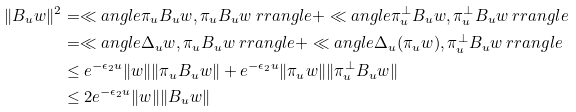<formula> <loc_0><loc_0><loc_500><loc_500>\| B _ { u } w \| ^ { 2 } & = \ll a n g l e \pi _ { u } B _ { u } w , \pi _ { u } B _ { u } w \ r r a n g l e + \ll a n g l e \pi _ { u } ^ { \perp } B _ { u } w , \pi _ { u } ^ { \perp } B _ { u } w \ r r a n g l e \\ & = \ll a n g l e \Delta _ { u } w , \pi _ { u } B _ { u } w \ r r a n g l e + \ll a n g l e \Delta _ { u } ( \pi _ { u } w ) , \pi _ { u } ^ { \perp } B _ { u } w \ r r a n g l e \\ & \leq e ^ { - \epsilon _ { 2 } u } \| w \| \| \pi _ { u } B _ { u } w \| + e ^ { - \epsilon _ { 2 } u } \| \pi _ { u } w \| \| \pi _ { u } ^ { \perp } B _ { u } w \| \\ & \leq 2 e ^ { - \epsilon _ { 2 } u } \| w \| \| B _ { u } w \|</formula> 